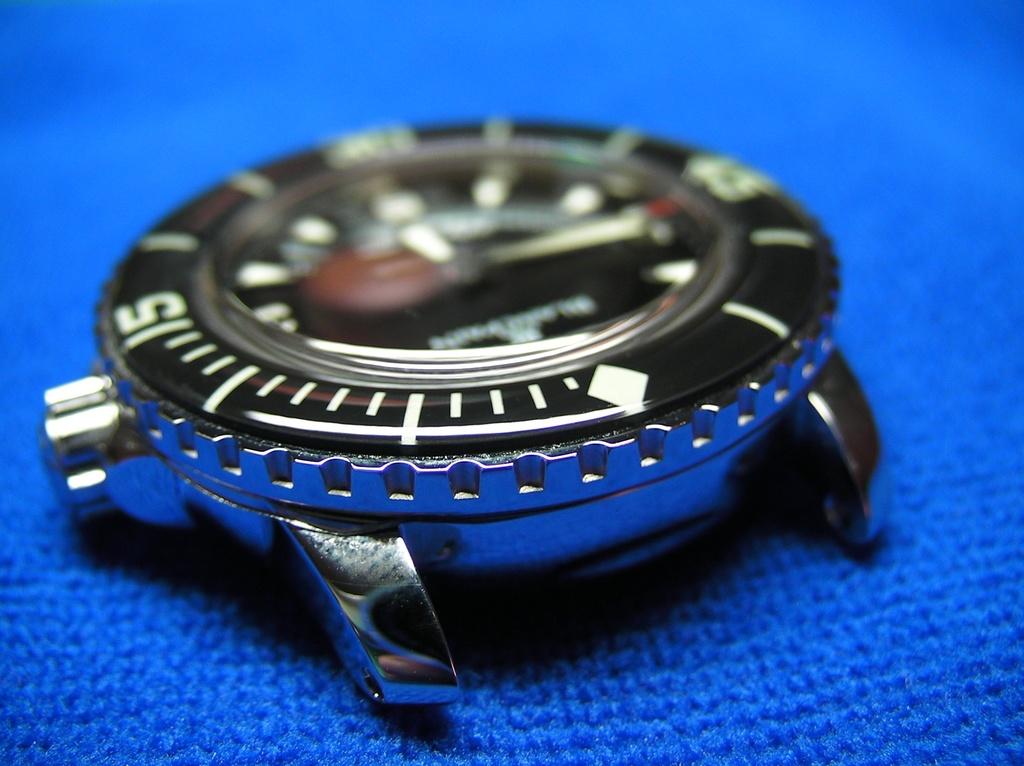What number is on the left?
Your answer should be compact. 15. 